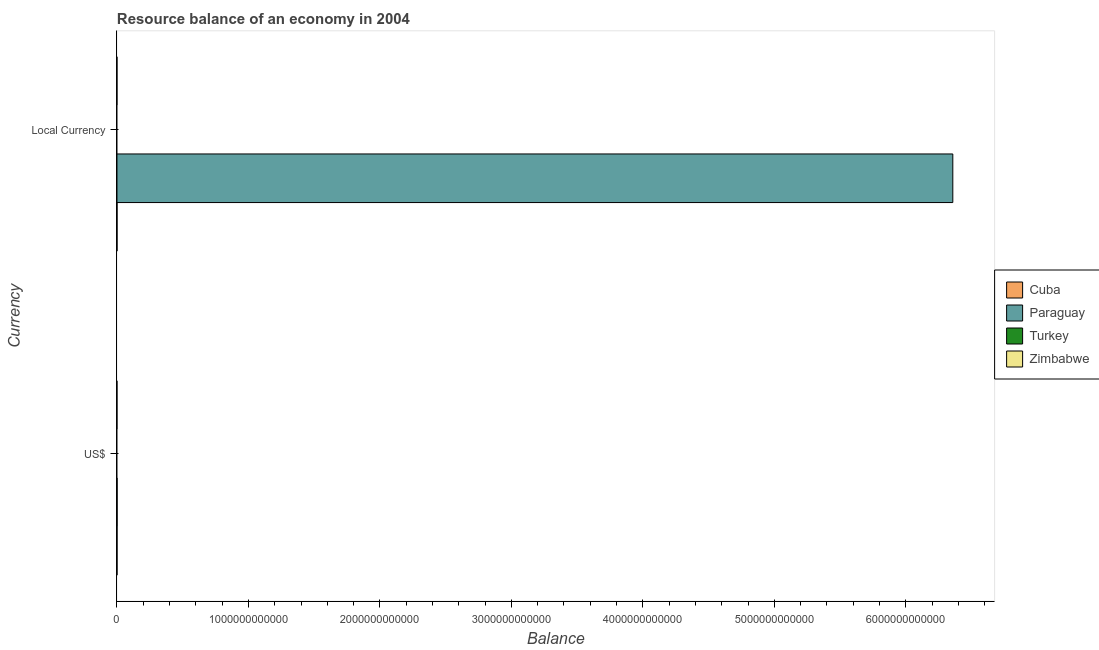How many different coloured bars are there?
Offer a very short reply. 2. Are the number of bars on each tick of the Y-axis equal?
Give a very brief answer. Yes. How many bars are there on the 1st tick from the top?
Your answer should be compact. 2. How many bars are there on the 2nd tick from the bottom?
Make the answer very short. 2. What is the label of the 1st group of bars from the top?
Your response must be concise. Local Currency. What is the resource balance in constant us$ in Paraguay?
Your answer should be very brief. 6.36e+12. Across all countries, what is the maximum resource balance in constant us$?
Give a very brief answer. 6.36e+12. In which country was the resource balance in us$ maximum?
Provide a short and direct response. Paraguay. What is the total resource balance in us$ in the graph?
Ensure brevity in your answer.  1.34e+09. What is the difference between the resource balance in us$ in Cuba and the resource balance in constant us$ in Paraguay?
Make the answer very short. -6.36e+12. What is the average resource balance in constant us$ per country?
Make the answer very short. 1.59e+12. What is the difference between the resource balance in constant us$ and resource balance in us$ in Cuba?
Give a very brief answer. 0. What is the ratio of the resource balance in us$ in Cuba to that in Paraguay?
Provide a succinct answer. 0.26. Is the resource balance in constant us$ in Paraguay less than that in Cuba?
Offer a terse response. No. In how many countries, is the resource balance in constant us$ greater than the average resource balance in constant us$ taken over all countries?
Offer a very short reply. 1. How many bars are there?
Keep it short and to the point. 4. What is the difference between two consecutive major ticks on the X-axis?
Make the answer very short. 1.00e+12. Does the graph contain any zero values?
Keep it short and to the point. Yes. Does the graph contain grids?
Provide a succinct answer. No. How many legend labels are there?
Your answer should be very brief. 4. What is the title of the graph?
Give a very brief answer. Resource balance of an economy in 2004. What is the label or title of the X-axis?
Make the answer very short. Balance. What is the label or title of the Y-axis?
Provide a short and direct response. Currency. What is the Balance in Cuba in US$?
Ensure brevity in your answer.  2.80e+08. What is the Balance of Paraguay in US$?
Provide a short and direct response. 1.06e+09. What is the Balance in Turkey in US$?
Your answer should be compact. 0. What is the Balance of Zimbabwe in US$?
Your answer should be compact. 0. What is the Balance in Cuba in Local Currency?
Provide a short and direct response. 2.80e+08. What is the Balance in Paraguay in Local Currency?
Give a very brief answer. 6.36e+12. What is the Balance of Turkey in Local Currency?
Make the answer very short. 0. Across all Currency, what is the maximum Balance of Cuba?
Give a very brief answer. 2.80e+08. Across all Currency, what is the maximum Balance of Paraguay?
Make the answer very short. 6.36e+12. Across all Currency, what is the minimum Balance of Cuba?
Offer a very short reply. 2.80e+08. Across all Currency, what is the minimum Balance of Paraguay?
Give a very brief answer. 1.06e+09. What is the total Balance of Cuba in the graph?
Your answer should be compact. 5.59e+08. What is the total Balance of Paraguay in the graph?
Make the answer very short. 6.36e+12. What is the total Balance in Turkey in the graph?
Keep it short and to the point. 0. What is the total Balance in Zimbabwe in the graph?
Provide a succinct answer. 0. What is the difference between the Balance in Cuba in US$ and that in Local Currency?
Give a very brief answer. 0. What is the difference between the Balance in Paraguay in US$ and that in Local Currency?
Your answer should be compact. -6.36e+12. What is the difference between the Balance of Cuba in US$ and the Balance of Paraguay in Local Currency?
Offer a very short reply. -6.36e+12. What is the average Balance in Cuba per Currency?
Your answer should be compact. 2.80e+08. What is the average Balance of Paraguay per Currency?
Your response must be concise. 3.18e+12. What is the average Balance in Turkey per Currency?
Offer a very short reply. 0. What is the difference between the Balance in Cuba and Balance in Paraguay in US$?
Your answer should be very brief. -7.84e+08. What is the difference between the Balance in Cuba and Balance in Paraguay in Local Currency?
Provide a succinct answer. -6.36e+12. What is the ratio of the Balance in Paraguay in US$ to that in Local Currency?
Provide a succinct answer. 0. What is the difference between the highest and the second highest Balance of Paraguay?
Make the answer very short. 6.36e+12. What is the difference between the highest and the lowest Balance of Paraguay?
Keep it short and to the point. 6.36e+12. 